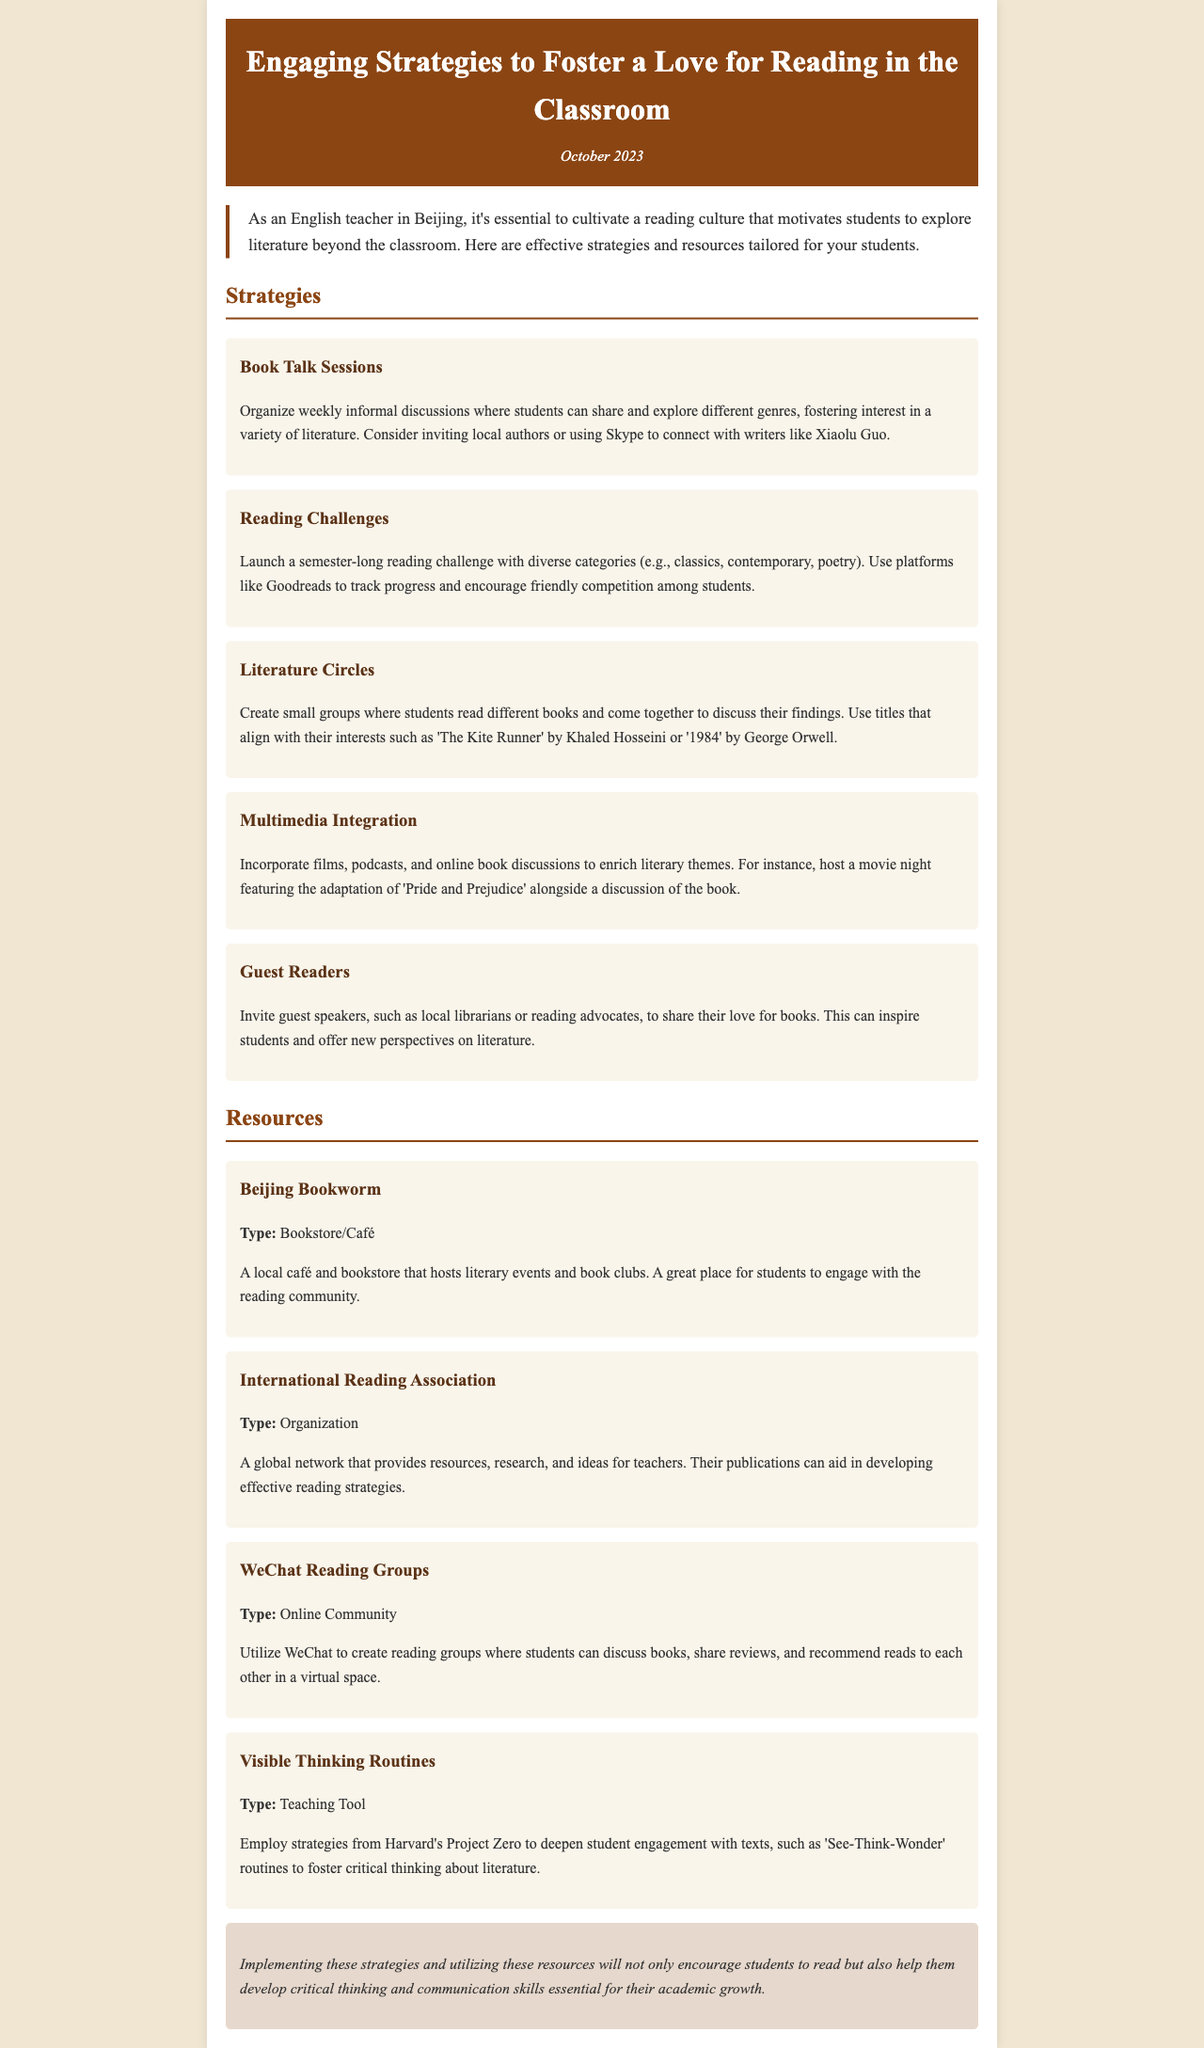what is the title of the newsletter? The title of the newsletter is prominently displayed in the header section of the document.
Answer: Engaging Strategies to Foster a Love for Reading in the Classroom when was the newsletter published? The publication date is mentioned below the title in the header.
Answer: October 2023 what is one example of a reading strategy mentioned? Multiple strategies are listed in the document under the respective section for strategies.
Answer: Book Talk Sessions which bookstore/café is recommended in the resources? The resources section includes various helpful resources, one of which is a bookstore.
Answer: Beijing Bookworm what type of organization is the International Reading Association? The type of organization is specified in the resources section.
Answer: Organization how can students engage virtually according to the document? The resources section provides a way for students to connect online.
Answer: WeChat Reading Groups what is a teaching tool mentioned in the resources? The document lists different tools and resources to enhance reading engagement.
Answer: Visible Thinking Routines what is the main goal of implementing the strategies mentioned? The conclusion summarizes the purpose of the strategies highlighted in the document.
Answer: Encourage students to read 